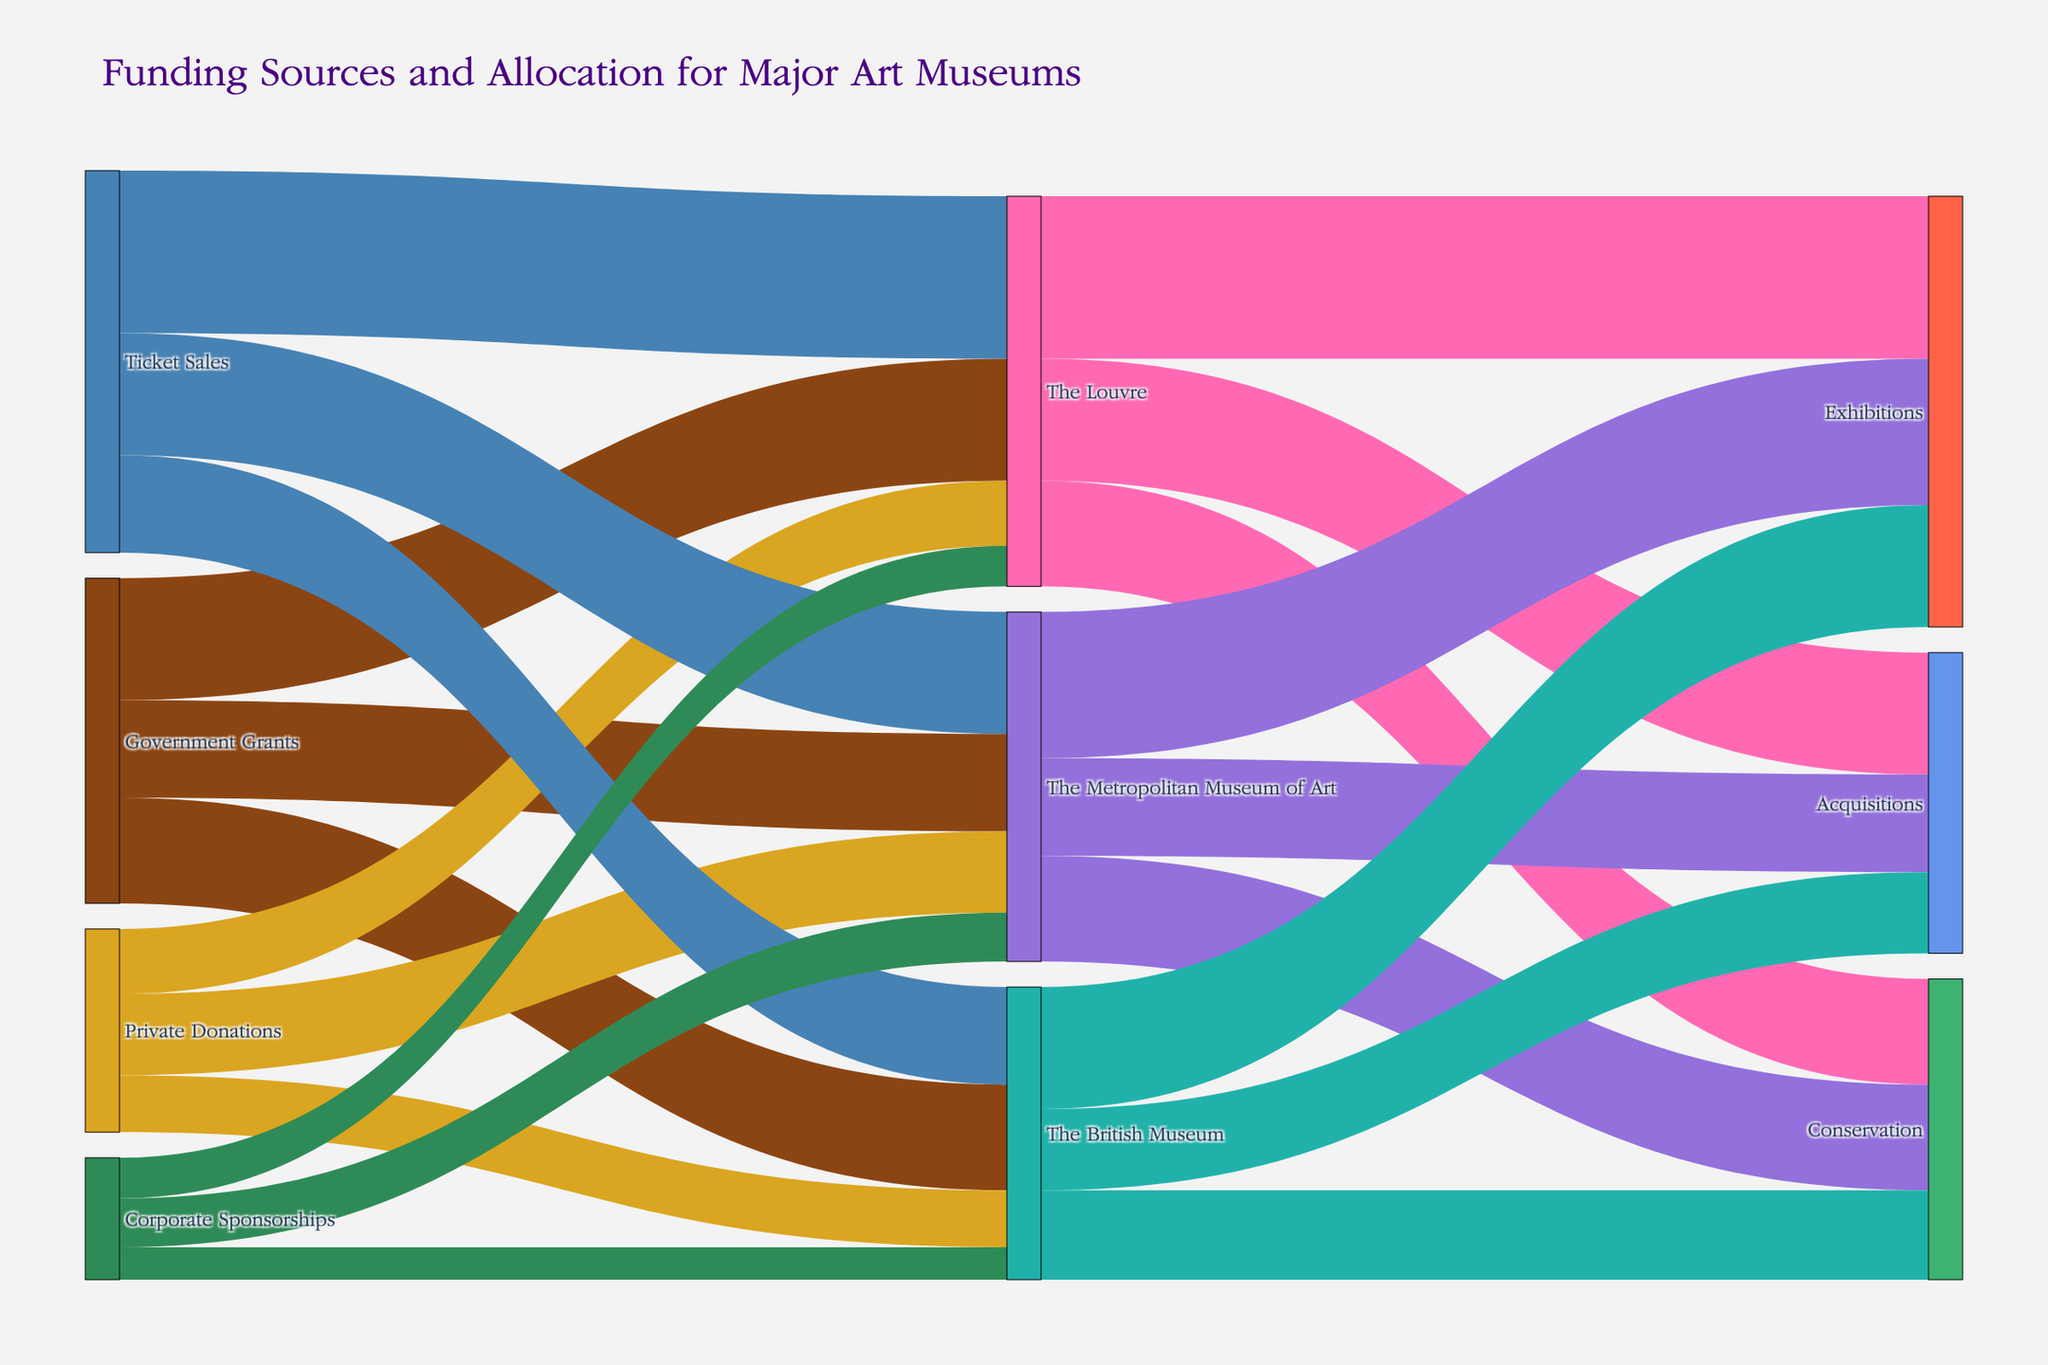What is the title of the figure? The title appears at the top of the figure and summarizes the data being represented. It reads "Funding Sources and Allocation for Major Art Museums".
Answer: Funding Sources and Allocation for Major Art Museums Which museum receives the most funding from government grants? By looking at the thickness and labeling of the links originating from "Government Grants", we find that "The Louvre" receives the highest funding of 150 units.
Answer: The Louvre How much total funding does the British Museum receive? Sum up all the funding directed to "The British Museum" from different sources: Government Grants (130) + Private Donations (70) + Ticket Sales (120) + Corporate Sponsorships (40).
Answer: 360 Which funding source contributes the least to "The Metropolitan Museum of Art"? Examine the links directed to "The Metropolitan Museum of Art" and identify the source with the smallest value: Government Grants (120), Private Donations (100), Ticket Sales (150), Corporate Sponsorships (60). Corporate Sponsorships contributes the least with 60 units.
Answer: Corporate Sponsorships How much funding is allocated to exhibitions by the three museums combined? Sum up the allocations to "Exhibitions": The Louvre (200), The Metropolitan Museum of Art (180), The British Museum (150).
Answer: 530 Compare the funding from ticket sales for "The Metropolitan Museum of Art" and "The British Museum". Which one is higher? Review the figures for ticket sales to both museums: The Metropolitan Museum of Art (150) and The British Museum (120). The Metropolitan Museum of Art has higher ticket sales.
Answer: The Metropolitan Museum of Art What is the total amount of funding contributions for conservation in The Louvre and The British Museum combined? Sum up the funding for "Conservation" in both museums: The Louvre (130) + The British Museum (110).
Answer: 240 Which museum receives higher contributions from private donations, and by how much? Compare private donations to "The Louvre" (80) and "The Metropolitan Museum of Art" (100). The Metropolitan Museum of Art receives more by 100 - 80.
Answer: The Metropolitan Museum of Art, 20 Out of all the funding sources, which one allocates the most resources to all three museums combined? Sum up funds from each source across all museums: Government Grants (150+120+130=400), Private Donations (80+100+70=250), Ticket Sales (200+150+120=470), Corporate Sponsorships (50+60+40=150). Ticket Sales provide the most with 470 units total.
Answer: Ticket Sales 